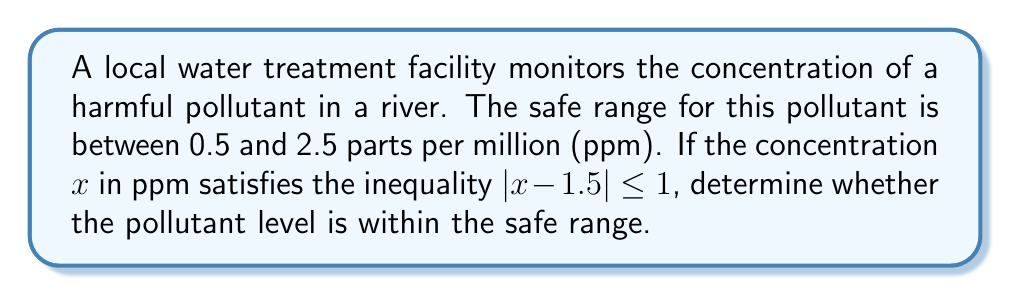Teach me how to tackle this problem. Let's approach this step-by-step:

1) The inequality $|x - 1.5| \leq 1$ describes the range of possible pollutant concentrations.

2) To solve this, we need to rewrite the absolute value inequality:
   $-1 \leq x - 1.5 \leq 1$

3) Add 1.5 to all parts of the inequality:
   $-1 + 1.5 \leq x - 1.5 + 1.5 \leq 1 + 1.5$
   $0.5 \leq x \leq 2.5$

4) This means the pollutant concentration $x$ is between 0.5 and 2.5 ppm, inclusive.

5) Comparing with the given safe range (0.5 to 2.5 ppm), we can see that the pollutant level described by the inequality exactly matches the safe range.

Therefore, the pollutant level is within the safe range.
Answer: Yes, within safe range 